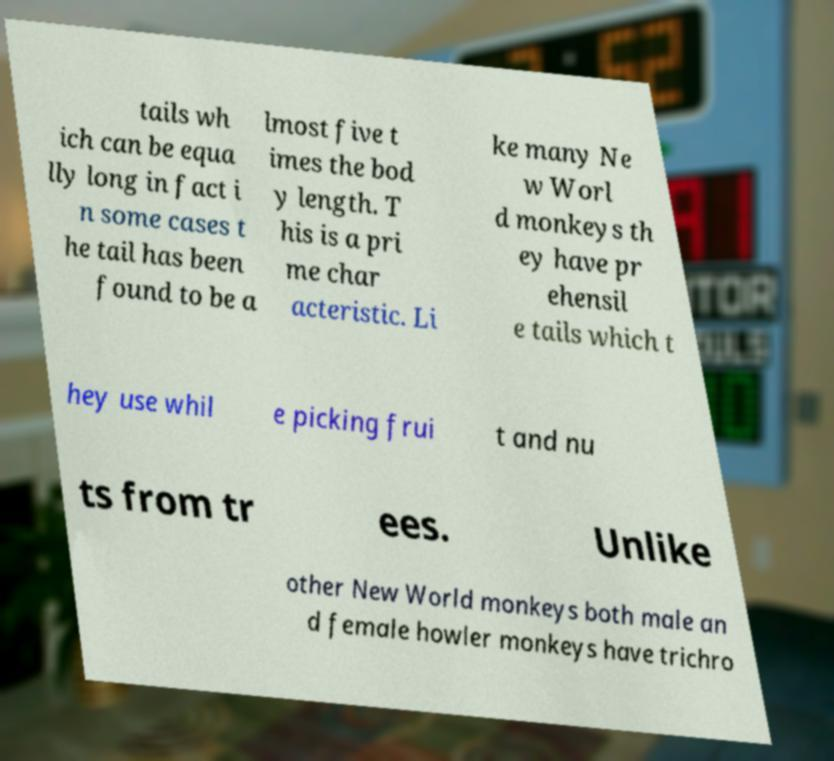Please read and relay the text visible in this image. What does it say? tails wh ich can be equa lly long in fact i n some cases t he tail has been found to be a lmost five t imes the bod y length. T his is a pri me char acteristic. Li ke many Ne w Worl d monkeys th ey have pr ehensil e tails which t hey use whil e picking frui t and nu ts from tr ees. Unlike other New World monkeys both male an d female howler monkeys have trichro 